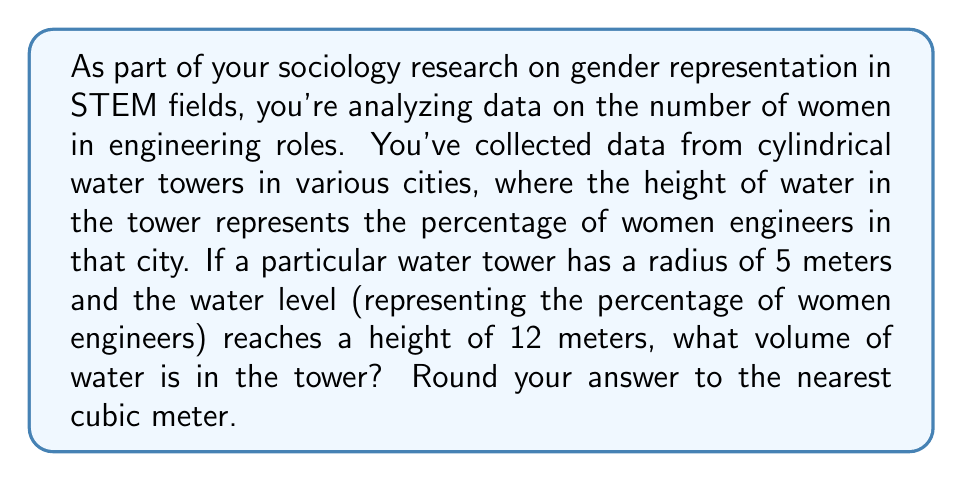Give your solution to this math problem. To solve this problem, we need to use the formula for the volume of a cylinder:

$$V = \pi r^2 h$$

Where:
$V$ = volume
$r$ = radius of the base
$h$ = height of the cylinder

Given:
$r = 5$ meters
$h = 12$ meters

Let's substitute these values into the formula:

$$V = \pi (5\text{ m})^2 (12\text{ m})$$

Now, let's calculate step by step:

1) First, calculate $r^2$:
   $5^2 = 25$

2) Multiply by $\pi$:
   $25\pi \approx 78.54$

3) Multiply by the height:
   $78.54 \times 12 = 942.48$

Therefore, the volume is approximately 942.48 cubic meters.

Rounding to the nearest cubic meter, we get 942 cubic meters.

This volume represents the proportion of women engineers in this particular city, with the full volume of the water tower representing 100% of engineers.
Answer: 942 cubic meters 